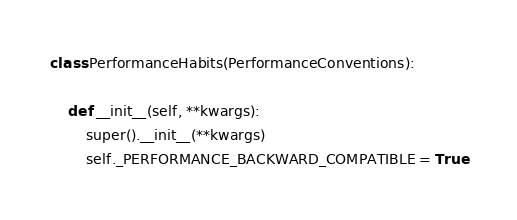Convert code to text. <code><loc_0><loc_0><loc_500><loc_500><_Python_>class PerformanceHabits(PerformanceConventions):

    def __init__(self, **kwargs):
        super().__init__(**kwargs)
        self._PERFORMANCE_BACKWARD_COMPATIBLE = True
</code> 